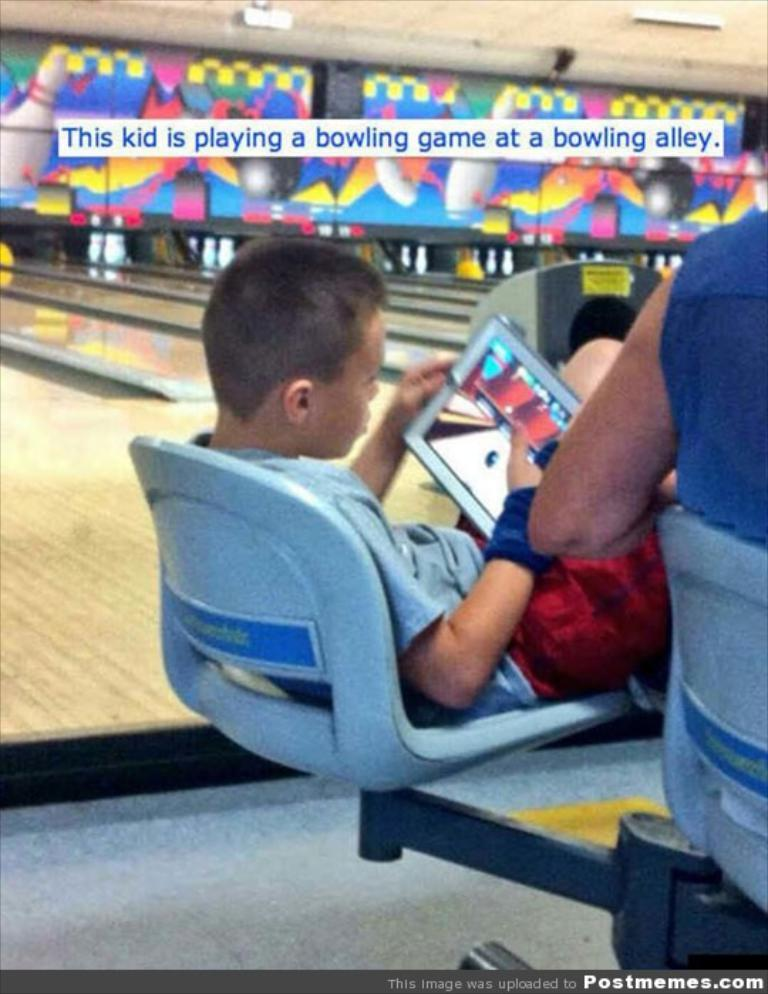Provide a one-sentence caption for the provided image. a kid playing a game on his tablet with the word bowling above him. 